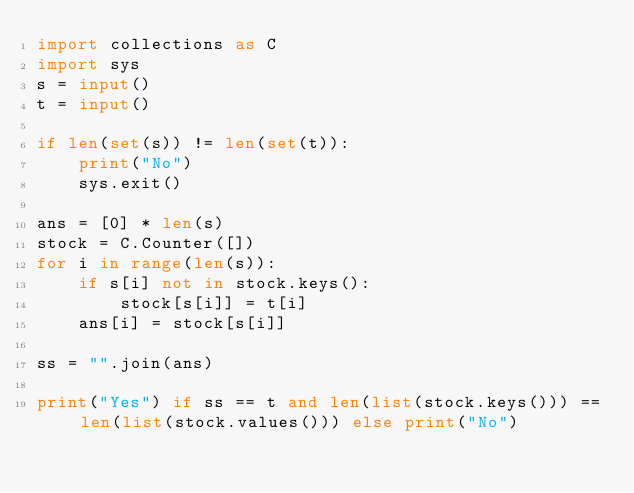<code> <loc_0><loc_0><loc_500><loc_500><_Python_>import collections as C
import sys
s = input()
t = input()

if len(set(s)) != len(set(t)):
    print("No")
    sys.exit()

ans = [0] * len(s)
stock = C.Counter([])
for i in range(len(s)):
    if s[i] not in stock.keys():
        stock[s[i]] = t[i]
    ans[i] = stock[s[i]]

ss = "".join(ans)

print("Yes") if ss == t and len(list(stock.keys())) == len(list(stock.values())) else print("No")
</code> 